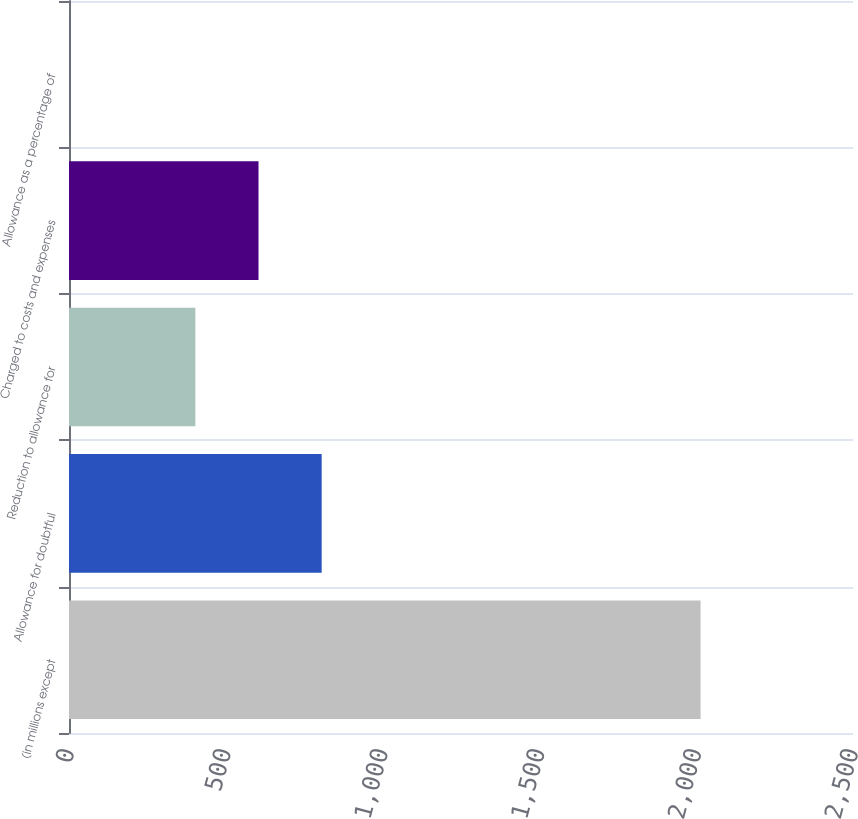<chart> <loc_0><loc_0><loc_500><loc_500><bar_chart><fcel>(in millions except<fcel>Allowance for doubtful<fcel>Reduction to allowance for<fcel>Charged to costs and expenses<fcel>Allowance as a percentage of<nl><fcel>2014<fcel>805.69<fcel>402.93<fcel>604.31<fcel>0.17<nl></chart> 